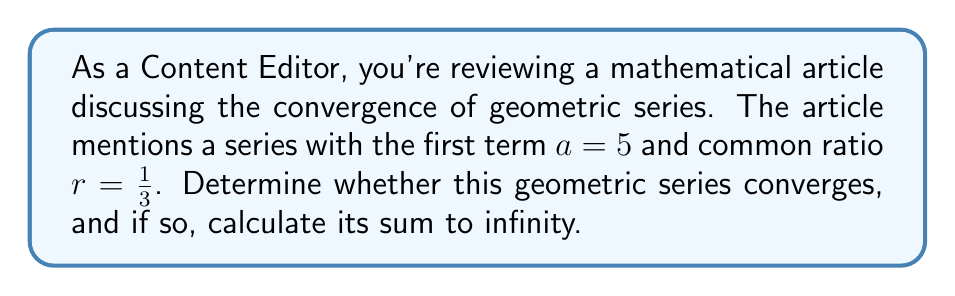Teach me how to tackle this problem. Let's approach this step-by-step:

1) First, recall that a geometric series converges if and only if $|r| < 1$, where $r$ is the common ratio.

2) In this case, $r = \frac{1}{3}$. Clearly, $|\frac{1}{3}| < 1$, so this series converges.

3) For a converging geometric series, the sum to infinity is given by the formula:

   $$S_{\infty} = \frac{a}{1-r}$$

   where $a$ is the first term and $r$ is the common ratio.

4) We're given that $a = 5$ and $r = \frac{1}{3}$. Let's substitute these into our formula:

   $$S_{\infty} = \frac{5}{1-\frac{1}{3}}$$

5) Simplify the denominator:
   
   $$S_{\infty} = \frac{5}{\frac{3}{3}-\frac{1}{3}} = \frac{5}{\frac{2}{3}}$$

6) To divide by a fraction, we multiply by its reciprocal:

   $$S_{\infty} = 5 \cdot \frac{3}{2} = \frac{15}{2} = 7.5$$

Therefore, the series converges to a sum of $\frac{15}{2}$ or 7.5.
Answer: The series converges; $S_{\infty} = \frac{15}{2}$ 